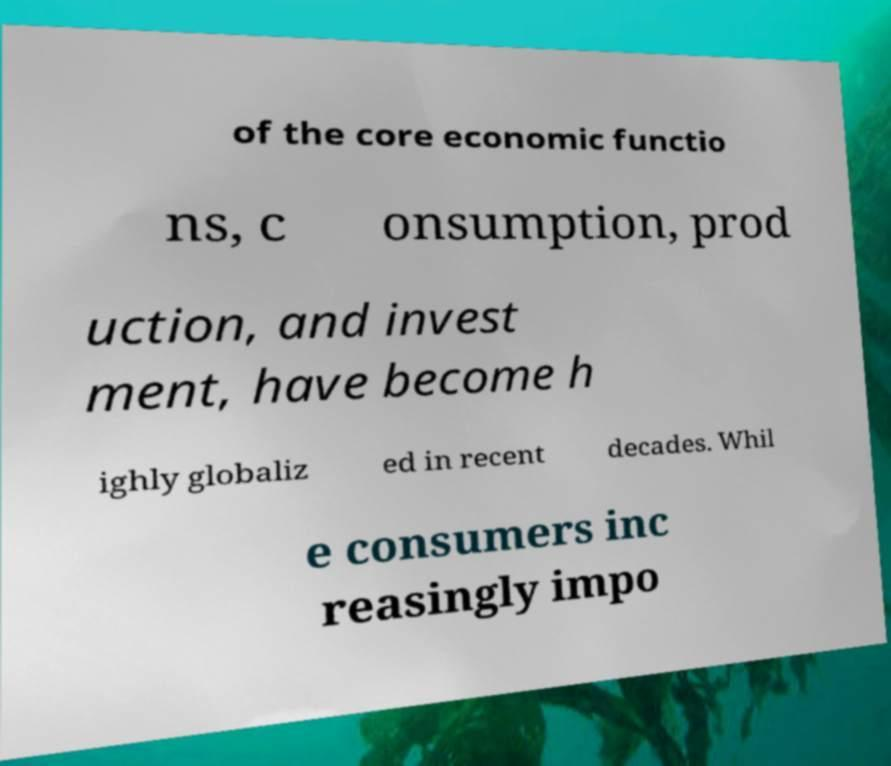Can you read and provide the text displayed in the image?This photo seems to have some interesting text. Can you extract and type it out for me? of the core economic functio ns, c onsumption, prod uction, and invest ment, have become h ighly globaliz ed in recent decades. Whil e consumers inc reasingly impo 